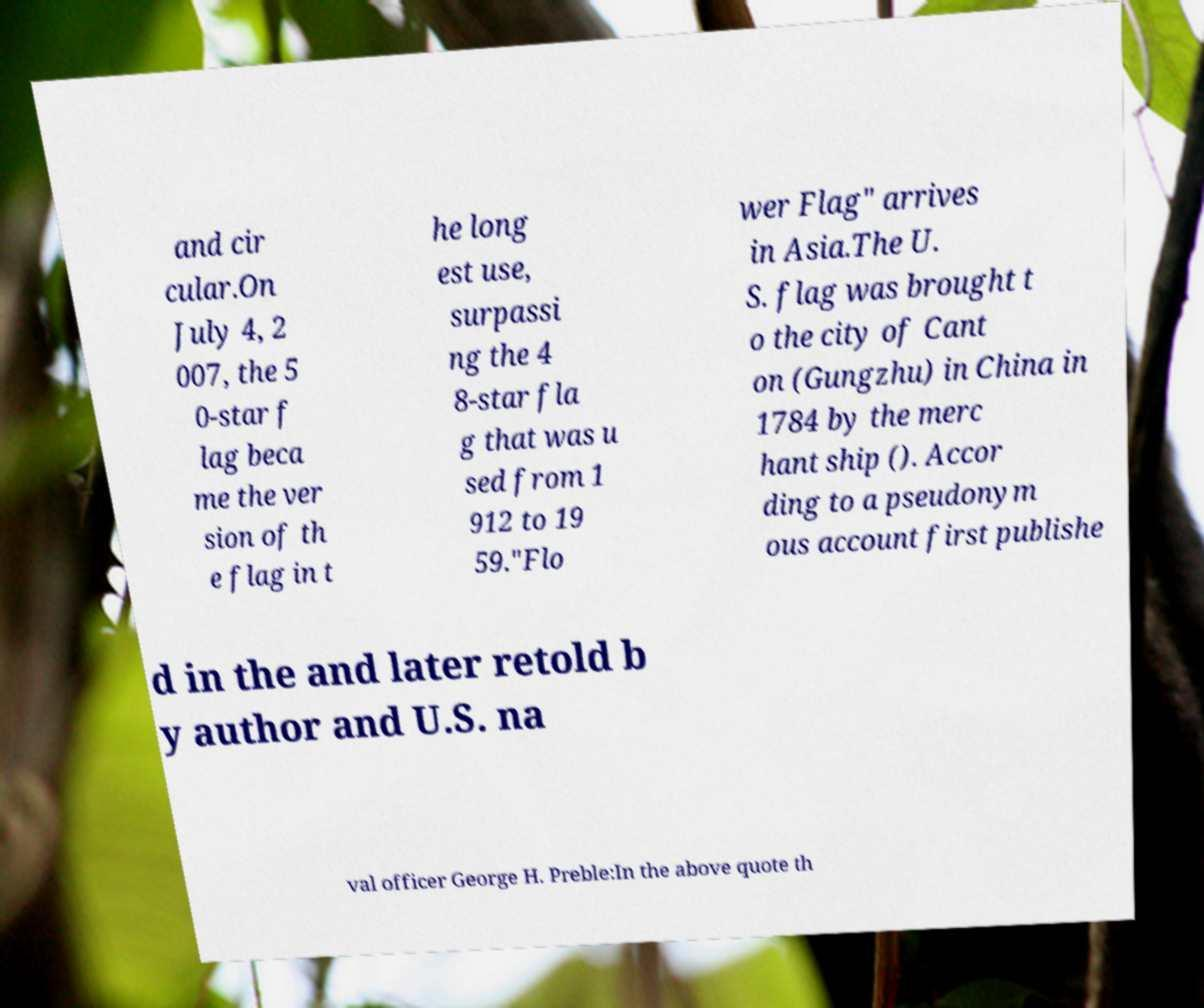Please read and relay the text visible in this image. What does it say? and cir cular.On July 4, 2 007, the 5 0-star f lag beca me the ver sion of th e flag in t he long est use, surpassi ng the 4 8-star fla g that was u sed from 1 912 to 19 59."Flo wer Flag" arrives in Asia.The U. S. flag was brought t o the city of Cant on (Gungzhu) in China in 1784 by the merc hant ship (). Accor ding to a pseudonym ous account first publishe d in the and later retold b y author and U.S. na val officer George H. Preble:In the above quote th 